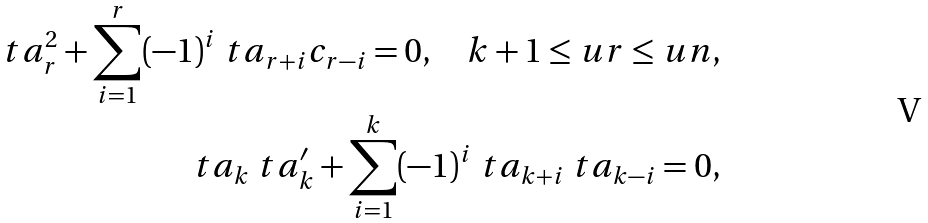Convert formula to latex. <formula><loc_0><loc_0><loc_500><loc_500>\ t a _ { r } ^ { 2 } + \sum _ { i = 1 } ^ { r } ( - 1 ) ^ { i } \ t a _ { r + i } c _ { r - i } = 0 , \ \ \ \ k + 1 \leq u r \leq u n , \\ \ t a _ { k } \ t a ^ { \prime } _ { k } + \sum _ { i = 1 } ^ { k } ( - 1 ) ^ { i } \ t a _ { k + i } \ t a _ { k - i } = 0 ,</formula> 